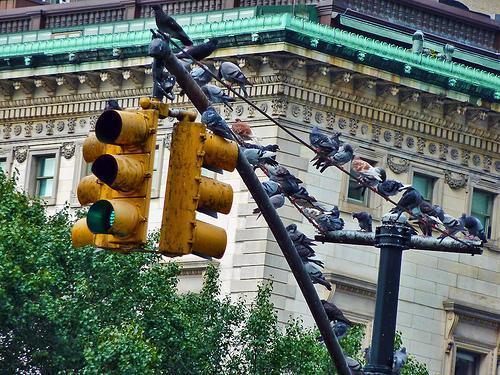How many traffic lights are on the pole?
Give a very brief answer. 3. How many traffic lights are on the picture?
Give a very brief answer. 3. 